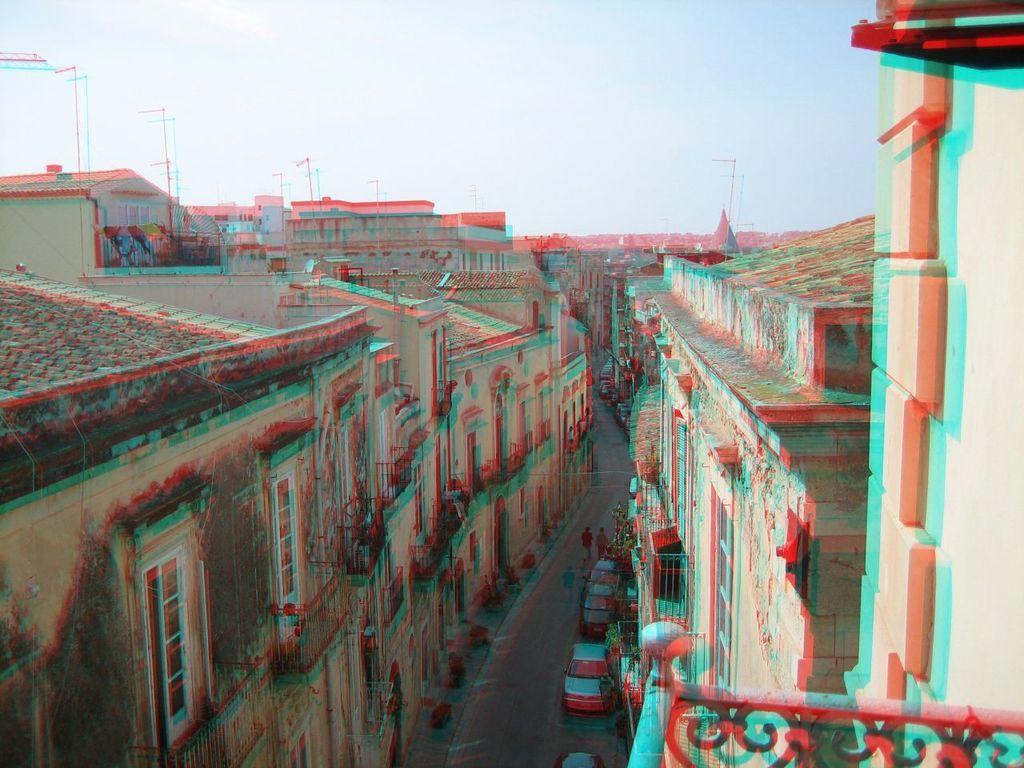What type of structures can be seen in the image? There are buildings in the image. What else can be seen in the image besides buildings? There are poles, people, grilles, and vehicles visible in the image. What is visible in the background of the image? The sky is visible in the image. What type of government is depicted in the image? There is no indication of a specific government in the image; it features buildings, poles, people, grilles, and vehicles. How many hands are visible in the image? There is no mention of hands in the provided facts, and therefore it cannot be determined how many hands are visible in the image. 